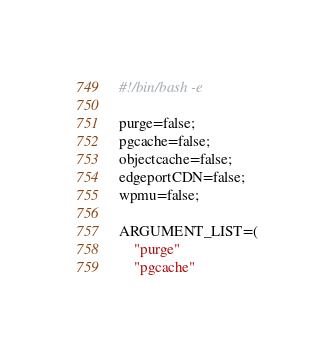<code> <loc_0><loc_0><loc_500><loc_500><_Bash_>#!/bin/bash -e

purge=false;
pgcache=false;
objectcache=false;
edgeportCDN=false;
wpmu=false;

ARGUMENT_LIST=(
    "purge"
    "pgcache"</code> 